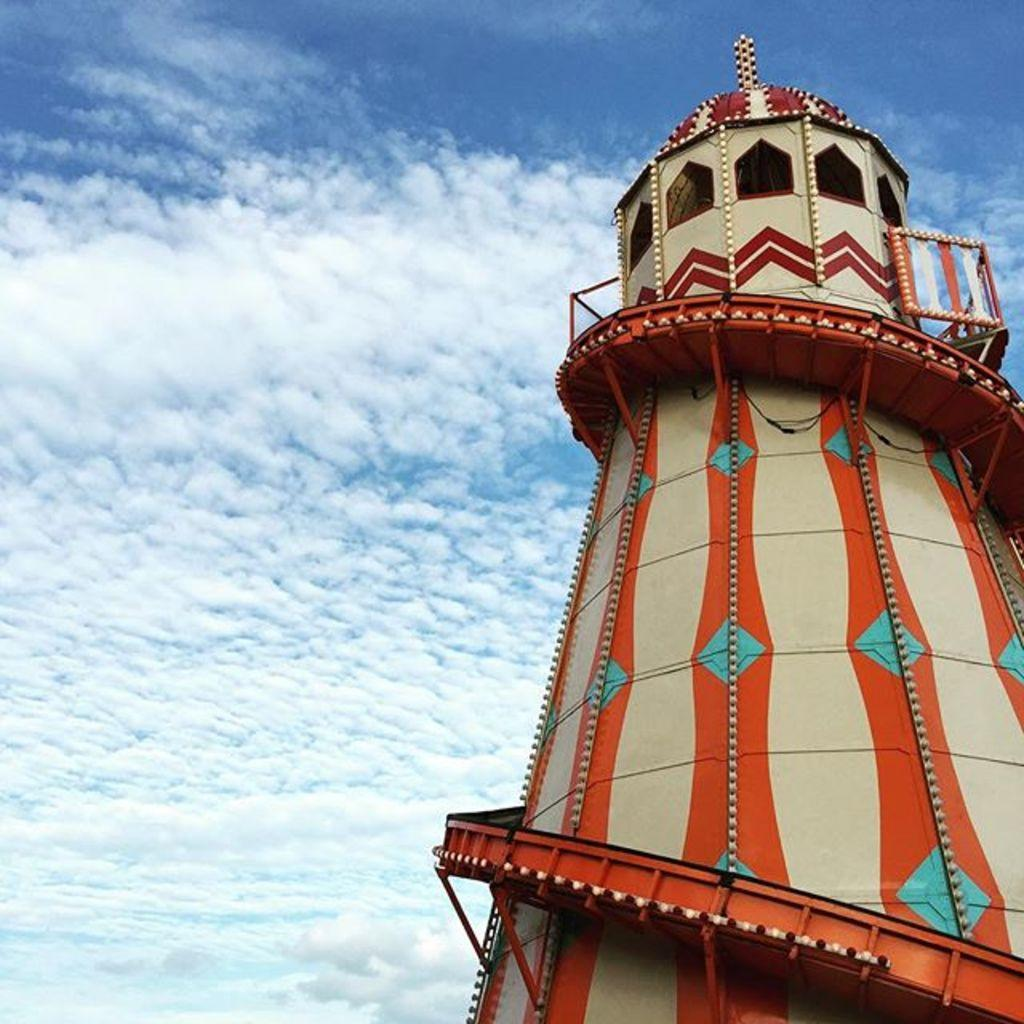What structure is the main subject of the image? There is an observation tower in the image. What is the condition of the sky in the image? The sky is fully covered with clouds in the image. Can you see any lines in the water for swimming in the image? There is no water or lines for swimming present in the image; it features an observation tower and a cloudy sky. 